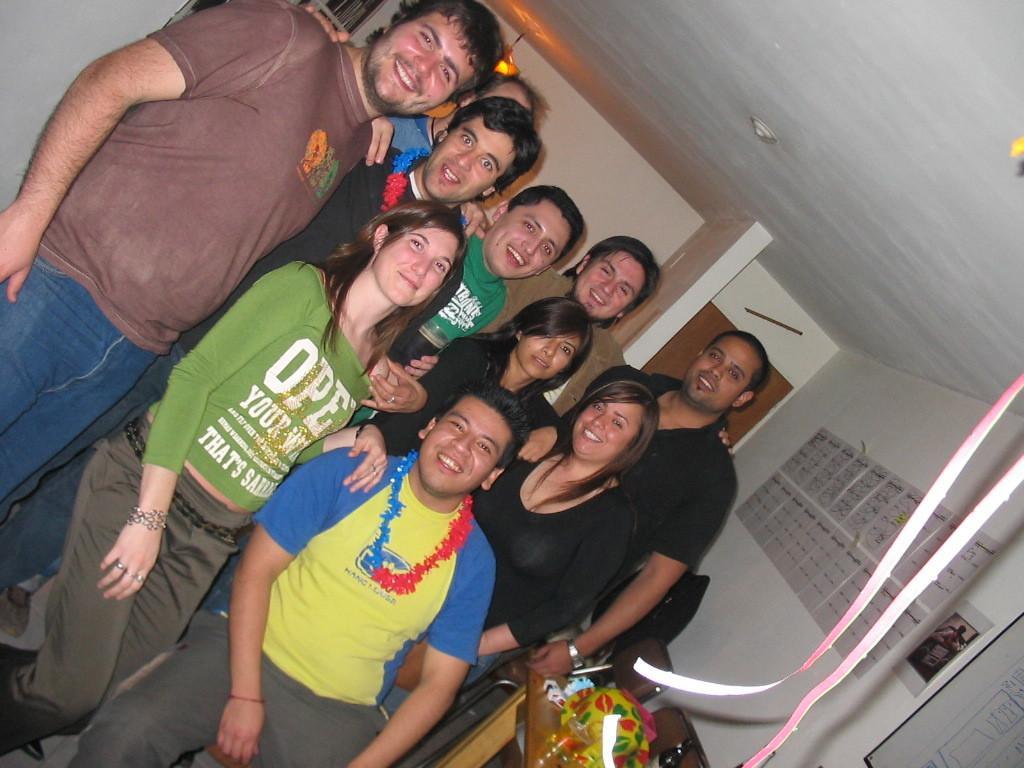Describe this image in one or two sentences. In this image I can see in the middle a group of people are standing and smiling. At the back side there is the light, on the right side few papers are sticked to the wall. 